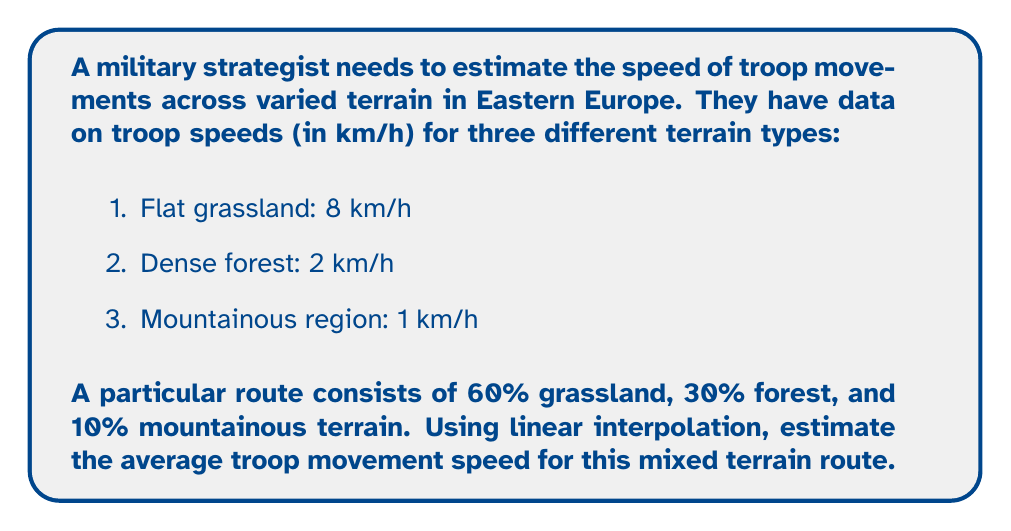Solve this math problem. To solve this problem, we'll use linear interpolation to estimate the average troop movement speed across the mixed terrain.

1. First, let's define our variables:
   $x_1 = 8$ km/h (grassland)
   $x_2 = 2$ km/h (forest)
   $x_3 = 1$ km/h (mountainous)
   
   $w_1 = 0.6$ (60% grassland)
   $w_2 = 0.3$ (30% forest)
   $w_3 = 0.1$ (10% mountainous)

2. The linear interpolation formula for multiple points is:

   $$v = \sum_{i=1}^n w_i x_i$$

   where $v$ is the interpolated value, $w_i$ are the weights, and $x_i$ are the known values.

3. Substituting our values into the formula:

   $$v = (0.6 \times 8) + (0.3 \times 2) + (0.1 \times 1)$$

4. Calculating each term:
   
   $$v = 4.8 + 0.6 + 0.1$$

5. Summing up the terms:

   $$v = 5.5$$

Therefore, the estimated average troop movement speed for this mixed terrain route is 5.5 km/h.
Answer: 5.5 km/h 